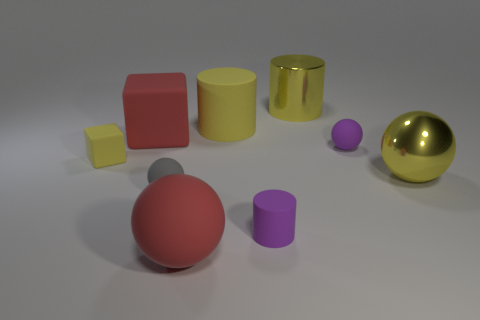What size is the cube that is the same color as the metal sphere?
Provide a succinct answer. Small. The purple matte object that is the same shape as the gray rubber thing is what size?
Make the answer very short. Small. How many red balls are the same material as the small gray sphere?
Your response must be concise. 1. Do the purple thing that is right of the yellow metallic cylinder and the red object that is in front of the small cylinder have the same size?
Give a very brief answer. No. Are there any other tiny objects that have the same shape as the tiny gray object?
Make the answer very short. Yes. Are there an equal number of yellow cylinders that are to the left of the small yellow object and small rubber blocks in front of the red ball?
Offer a terse response. Yes. Do the small yellow matte object and the big yellow matte thing have the same shape?
Make the answer very short. No. There is a ball that is the same color as the large metallic cylinder; what is it made of?
Make the answer very short. Metal. Is the purple rubber ball the same size as the purple matte cylinder?
Your response must be concise. Yes. What material is the red sphere that is the same size as the yellow matte cylinder?
Provide a succinct answer. Rubber. 